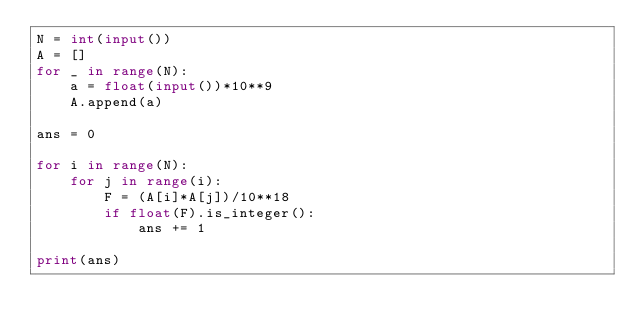<code> <loc_0><loc_0><loc_500><loc_500><_Python_>N = int(input())
A = []
for _ in range(N):
    a = float(input())*10**9
    A.append(a)

ans = 0

for i in range(N):
    for j in range(i):
        F = (A[i]*A[j])/10**18
        if float(F).is_integer():
            ans += 1

print(ans)
</code> 